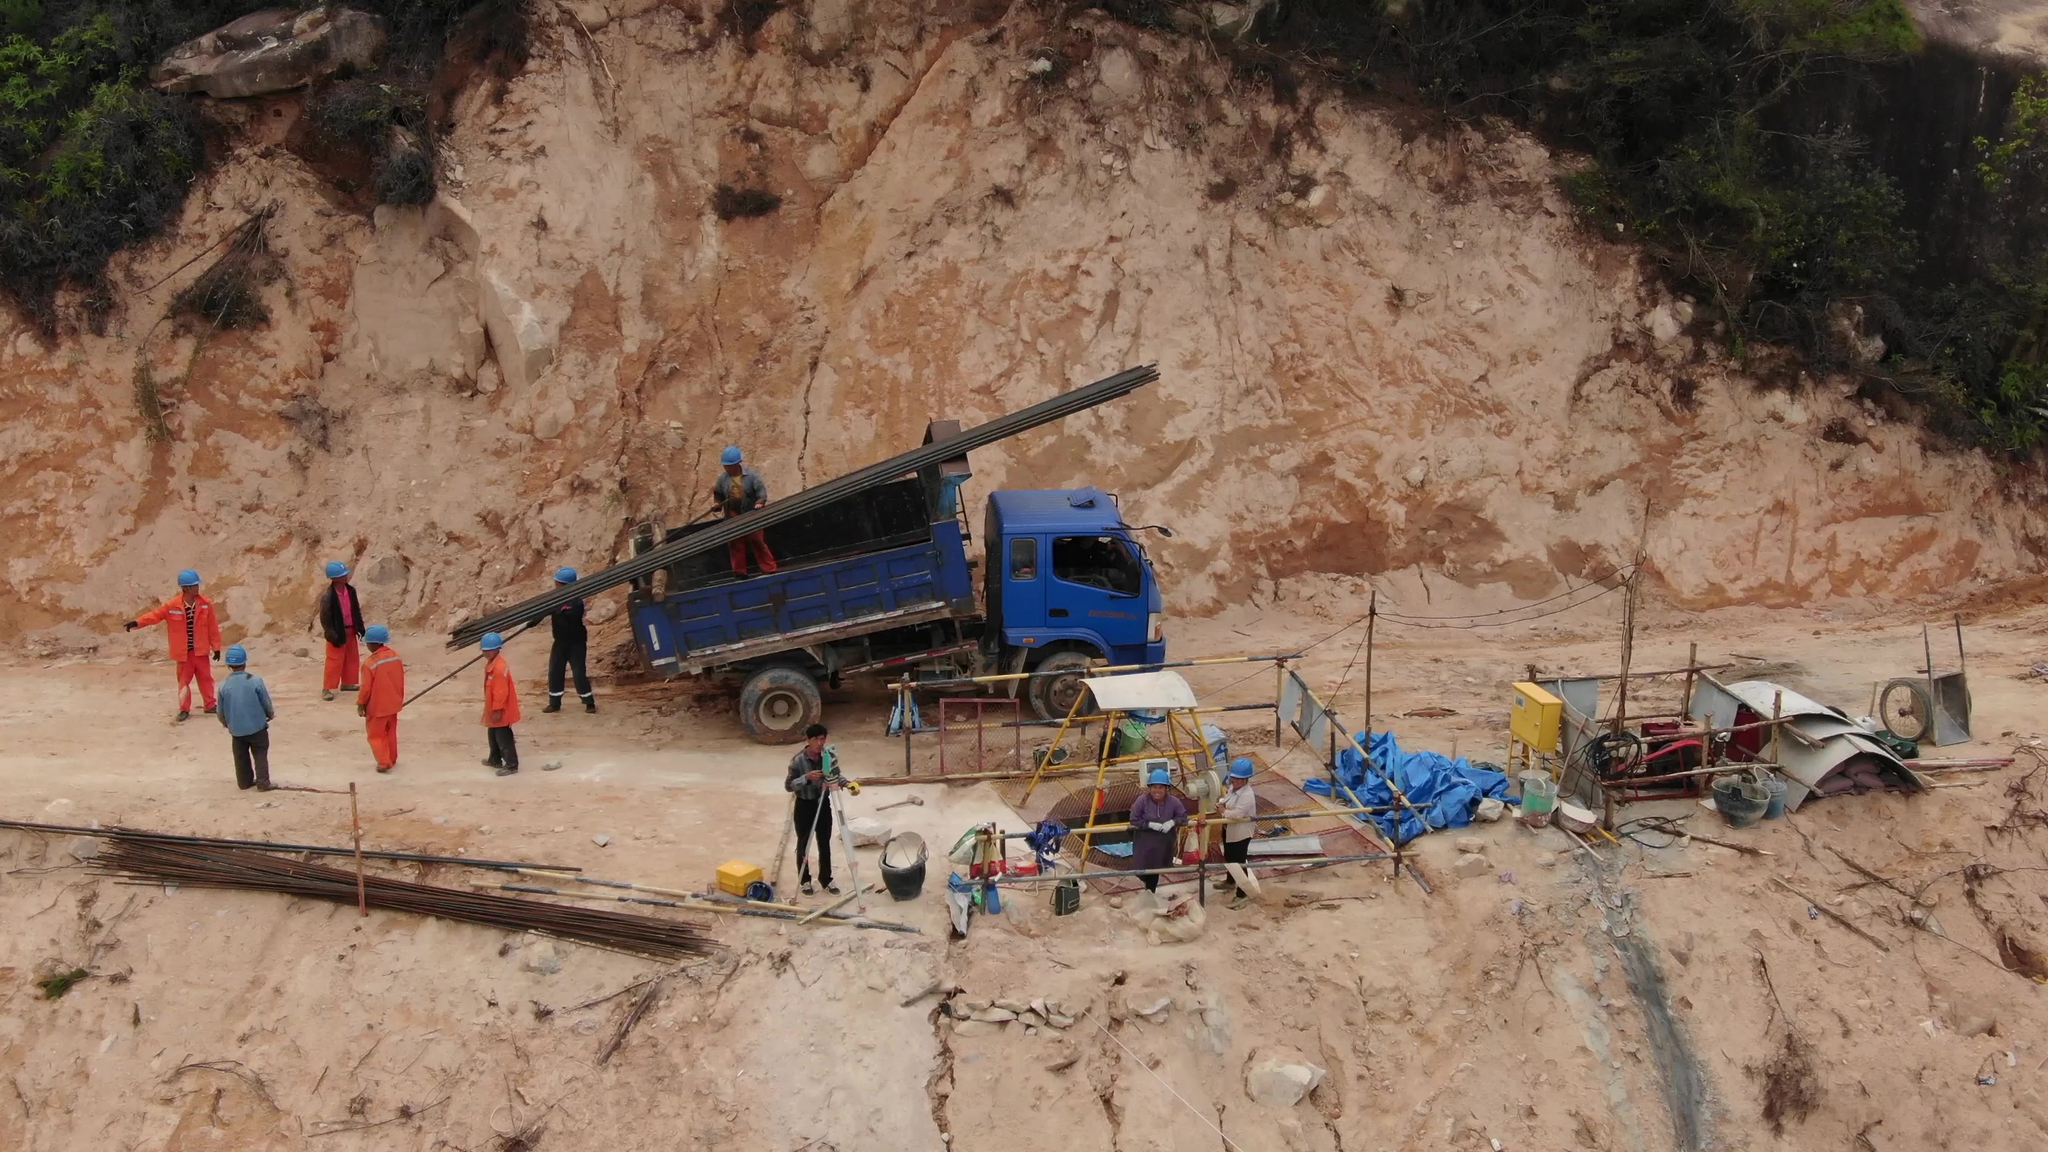pixel coordinates of person in this picture I'm unable to provide precise pixel coordinates for people in the image. However, I can help describe where the people are located in the image if that would be helpful.

For example:
- There are several people wearing helmets and working gear scattered across the image. Some are near the blue truck, some are on the left side, and a few are on the right side near construction equipment.

If you need pixel coordinates for a specific application, you might want to use image processing software or tools that allow you to click on the image to obtain the coordinates directly. 